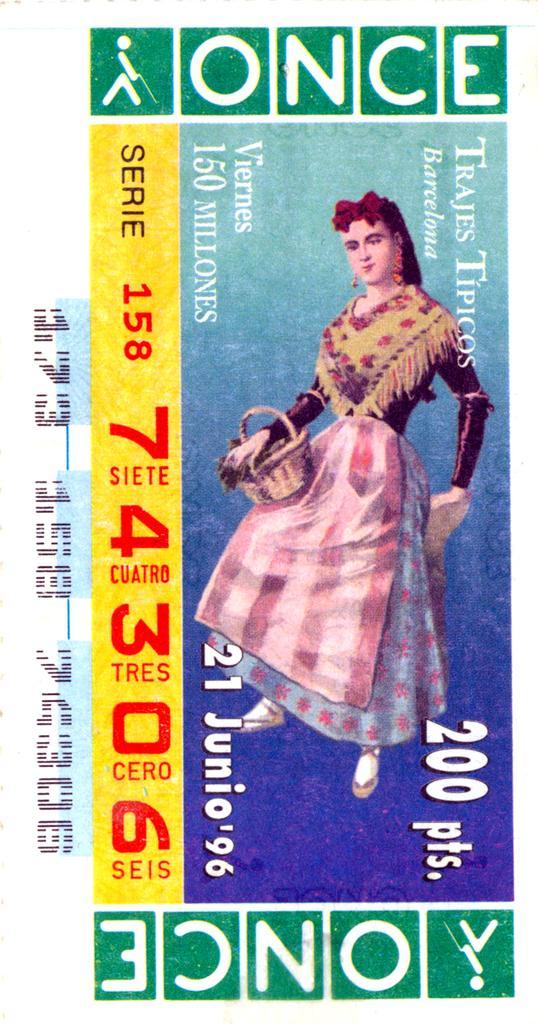Can you describe this image briefly? In this image I can see a woman's photo, numbers and a text. This image looks like a lottery ticket. 